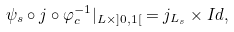<formula> <loc_0><loc_0><loc_500><loc_500>\psi _ { s } \circ j \circ \varphi _ { c } ^ { - 1 } | _ { L \times ] 0 , 1 [ } = j _ { L _ { s } } \times I d ,</formula> 